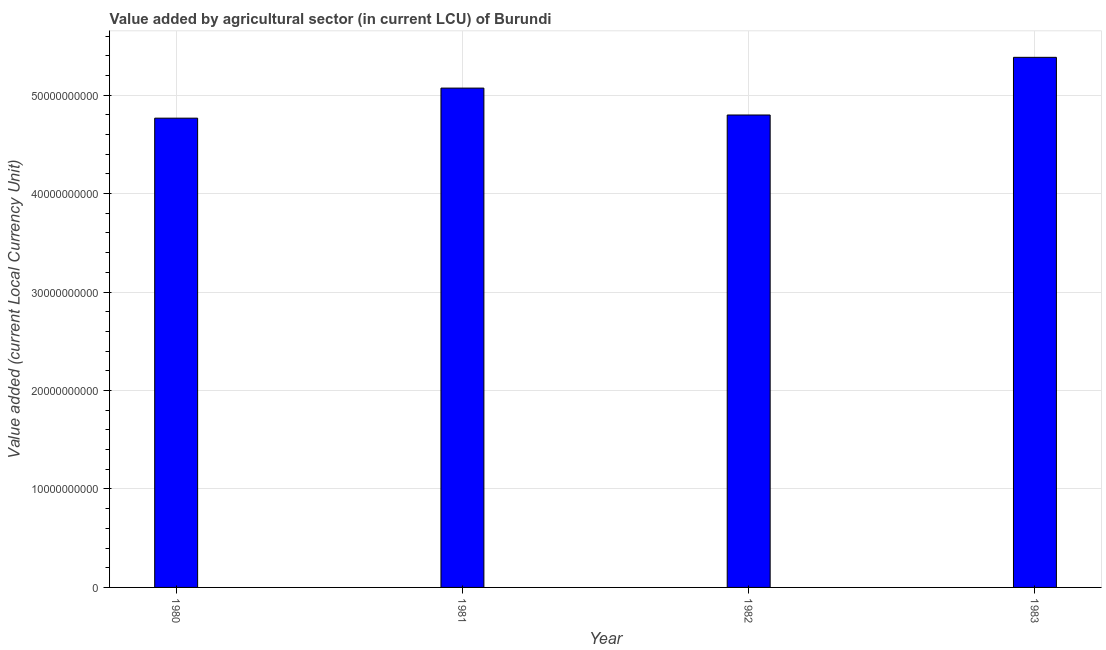Does the graph contain grids?
Keep it short and to the point. Yes. What is the title of the graph?
Offer a very short reply. Value added by agricultural sector (in current LCU) of Burundi. What is the label or title of the X-axis?
Your answer should be compact. Year. What is the label or title of the Y-axis?
Your answer should be very brief. Value added (current Local Currency Unit). What is the value added by agriculture sector in 1981?
Make the answer very short. 5.07e+1. Across all years, what is the maximum value added by agriculture sector?
Make the answer very short. 5.38e+1. Across all years, what is the minimum value added by agriculture sector?
Make the answer very short. 4.77e+1. In which year was the value added by agriculture sector maximum?
Keep it short and to the point. 1983. In which year was the value added by agriculture sector minimum?
Ensure brevity in your answer.  1980. What is the sum of the value added by agriculture sector?
Ensure brevity in your answer.  2.00e+11. What is the difference between the value added by agriculture sector in 1981 and 1983?
Your response must be concise. -3.13e+09. What is the average value added by agriculture sector per year?
Make the answer very short. 5.00e+1. What is the median value added by agriculture sector?
Your answer should be compact. 4.93e+1. Do a majority of the years between 1982 and 1981 (inclusive) have value added by agriculture sector greater than 4000000000 LCU?
Give a very brief answer. No. What is the ratio of the value added by agriculture sector in 1980 to that in 1982?
Your response must be concise. 0.99. Is the value added by agriculture sector in 1981 less than that in 1983?
Offer a very short reply. Yes. What is the difference between the highest and the second highest value added by agriculture sector?
Ensure brevity in your answer.  3.13e+09. What is the difference between the highest and the lowest value added by agriculture sector?
Provide a succinct answer. 6.18e+09. In how many years, is the value added by agriculture sector greater than the average value added by agriculture sector taken over all years?
Your answer should be very brief. 2. How many bars are there?
Your answer should be compact. 4. Are all the bars in the graph horizontal?
Offer a very short reply. No. How many years are there in the graph?
Keep it short and to the point. 4. What is the difference between two consecutive major ticks on the Y-axis?
Ensure brevity in your answer.  1.00e+1. Are the values on the major ticks of Y-axis written in scientific E-notation?
Offer a terse response. No. What is the Value added (current Local Currency Unit) of 1980?
Offer a terse response. 4.77e+1. What is the Value added (current Local Currency Unit) in 1981?
Give a very brief answer. 5.07e+1. What is the Value added (current Local Currency Unit) of 1982?
Provide a succinct answer. 4.80e+1. What is the Value added (current Local Currency Unit) of 1983?
Make the answer very short. 5.38e+1. What is the difference between the Value added (current Local Currency Unit) in 1980 and 1981?
Keep it short and to the point. -3.05e+09. What is the difference between the Value added (current Local Currency Unit) in 1980 and 1982?
Give a very brief answer. -3.22e+08. What is the difference between the Value added (current Local Currency Unit) in 1980 and 1983?
Provide a succinct answer. -6.18e+09. What is the difference between the Value added (current Local Currency Unit) in 1981 and 1982?
Offer a terse response. 2.73e+09. What is the difference between the Value added (current Local Currency Unit) in 1981 and 1983?
Your response must be concise. -3.13e+09. What is the difference between the Value added (current Local Currency Unit) in 1982 and 1983?
Offer a terse response. -5.86e+09. What is the ratio of the Value added (current Local Currency Unit) in 1980 to that in 1981?
Offer a very short reply. 0.94. What is the ratio of the Value added (current Local Currency Unit) in 1980 to that in 1983?
Your answer should be compact. 0.89. What is the ratio of the Value added (current Local Currency Unit) in 1981 to that in 1982?
Ensure brevity in your answer.  1.06. What is the ratio of the Value added (current Local Currency Unit) in 1981 to that in 1983?
Offer a terse response. 0.94. What is the ratio of the Value added (current Local Currency Unit) in 1982 to that in 1983?
Your response must be concise. 0.89. 